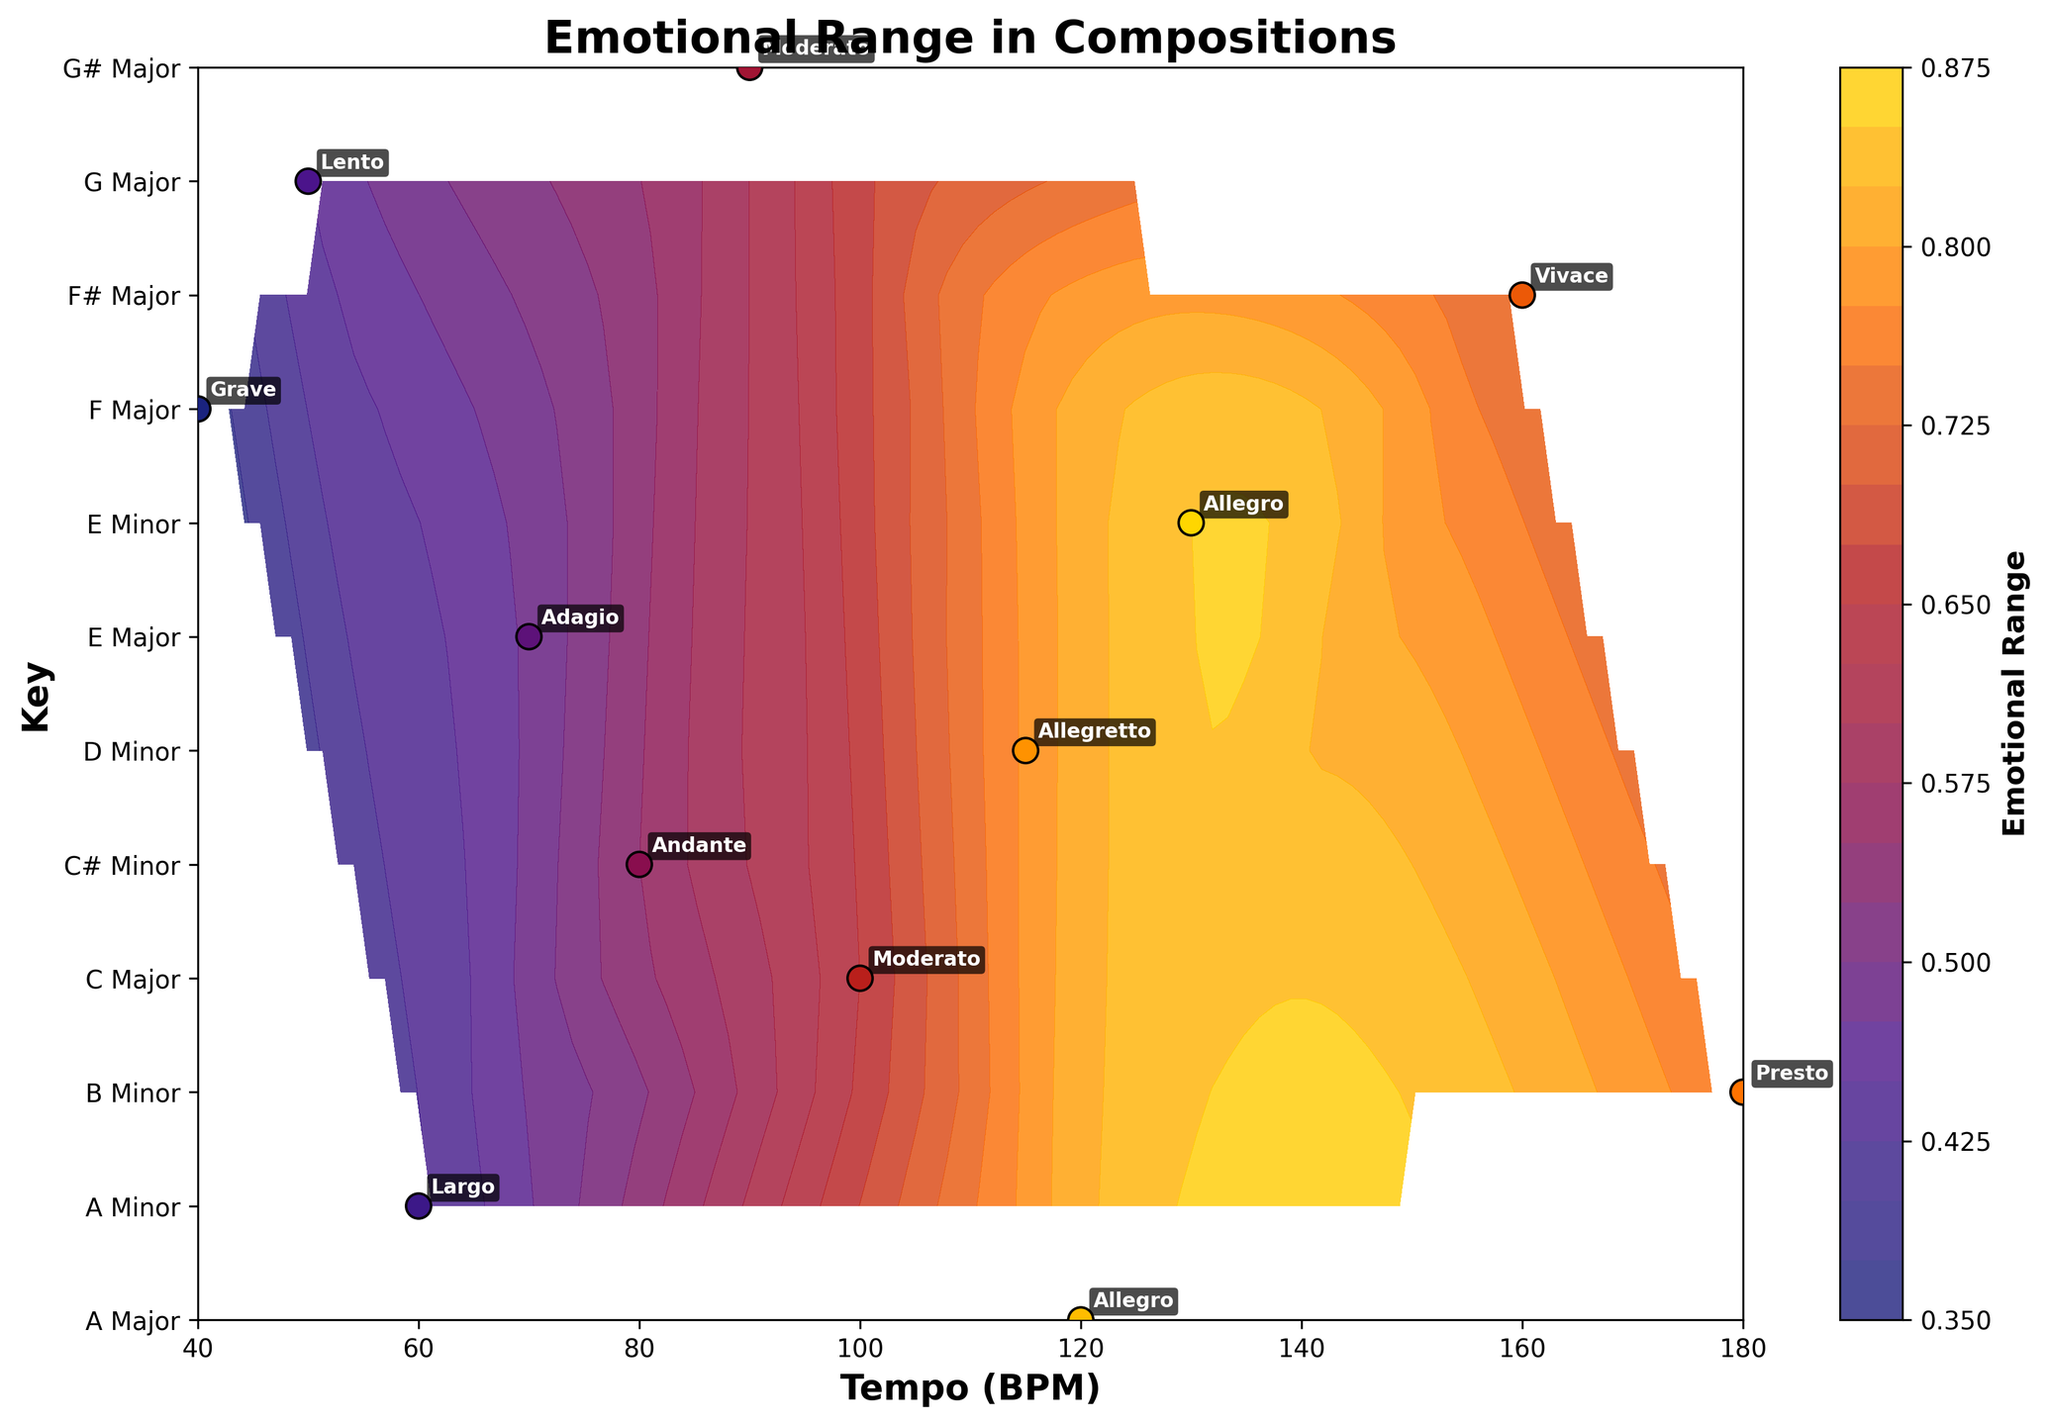What is the title of the plot? The title is clearly displayed at the top of the plot, displaying the main theme or subject of the figure.
Answer: Emotional Range in Compositions What are the x-axis and y-axis labels? The x-axis and y-axis labels provide information about what the axes represent. In this plot, the x-axis is labeled "Tempo (BPM)" representing beats per minute, and the y-axis is labeled "Key" representing the musical key.
Answer: Tempo (BPM), Key How many unique musical keys are there in the plot? The y-axis tick labels list the unique musical keys. By counting them, we can find there are 12 unique keys.
Answer: 12 Which key has the widest emotional range and at what tempo is it observed? By observing the color intensity and the contour levels in the plot, we can determine that "A Major" at around the tempo of 130 BPM has the highest emotional range of 0.85, indicated by the brightest color.
Answer: A Major, 130 BPM What is the minimum emotional range observed and in which key and tempo does it occur? The contour plot with lighter colors and labeled data points will indicate the minimum value. "E Minor" shows the lowest emotional range of 0.35 at a tempo of 40 BPM.
Answer: E Minor, 40 BPM How does the emotional range of compositions change as the tempo increases in "C Major"? By following the contour lines or interpolated shading changes along the "C Major" key line, we can observe that the emotional range increases from around 0.82 at 120 BPM.
Answer: It increases Which tempo groups are more likely to have higher emotional ranges based on the plot? By examining the shading colors over different tempo ranges, we notice that allegro (around 120-130 BPM) and vivace (around 160 BPM) tempi have higher emotional range values indicated by warmer colors.
Answer: Allegro and Vivace How does the emotional range of "E Major" compositions at 100 BPM compare to "F Major" compositions at 90 BPM? By observing the color shading and contour levels at the respective positions, we see that "E Major" at 100 BPM has an emotional range of 0.65 while "F Major" at 90 BPM has 0.60. Thus, "E Major" at 100 BPM has a slightly higher range.
Answer: E Major at 100 BPM is higher What is the average emotional range for compositions in minor keys based on the plot? The minor keys are A Minor, B Minor, D Minor, E Minor, and C# Minor. Their emotional ranges are 0.75, 0.55, 0.48, 0.35, and 0.72 respectively. Summing them up gives 0.75 + 0.55 + 0.48 + 0.35 + 0.72 = 2.85. Dividing by 5 gives the average: 2.85 / 5 = 0.57.
Answer: 0.57 